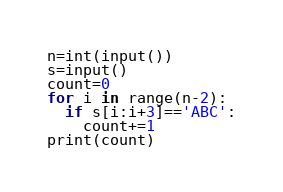<code> <loc_0><loc_0><loc_500><loc_500><_Python_>n=int(input())
s=input()
count=0
for i in range(n-2):
  if s[i:i+3]=='ABC':
    count+=1
print(count)</code> 